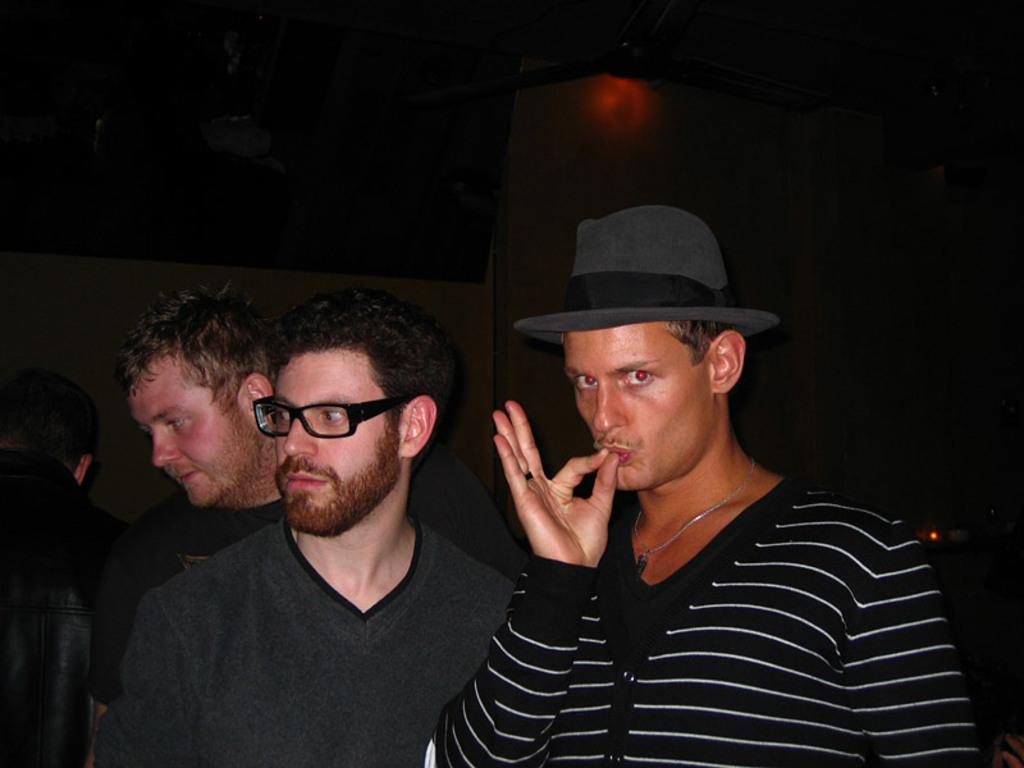What is the main subject of the image? The main subject of the image is a group of men. Can you describe any specific clothing or accessories worn by one of the men? One man is wearing a hat. What can be seen in the background or surrounding the men? There is a light visible in the image, and a ceiling fan is present. How many zebras can be seen in the image? There are no zebras present in the image. What day of the week is depicted in the image? The day of the week is not mentioned or depicted in the image. 